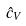<formula> <loc_0><loc_0><loc_500><loc_500>\hat { c } _ { V }</formula> 